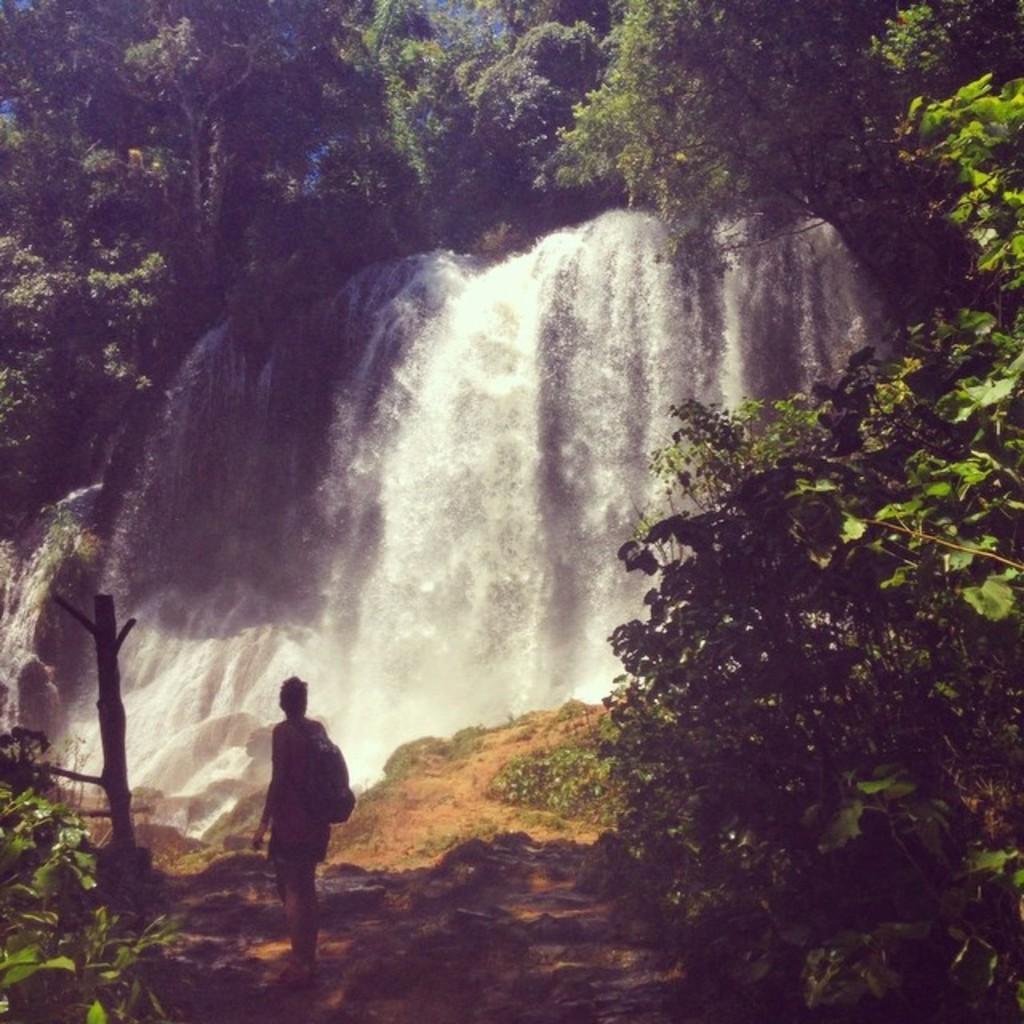Please provide a concise description of this image. In this picture I can observe a person standing on the land. I can observe some stones on the bottom of the picture. There are waterfalls. I can observe some trees and plants in this picture. 